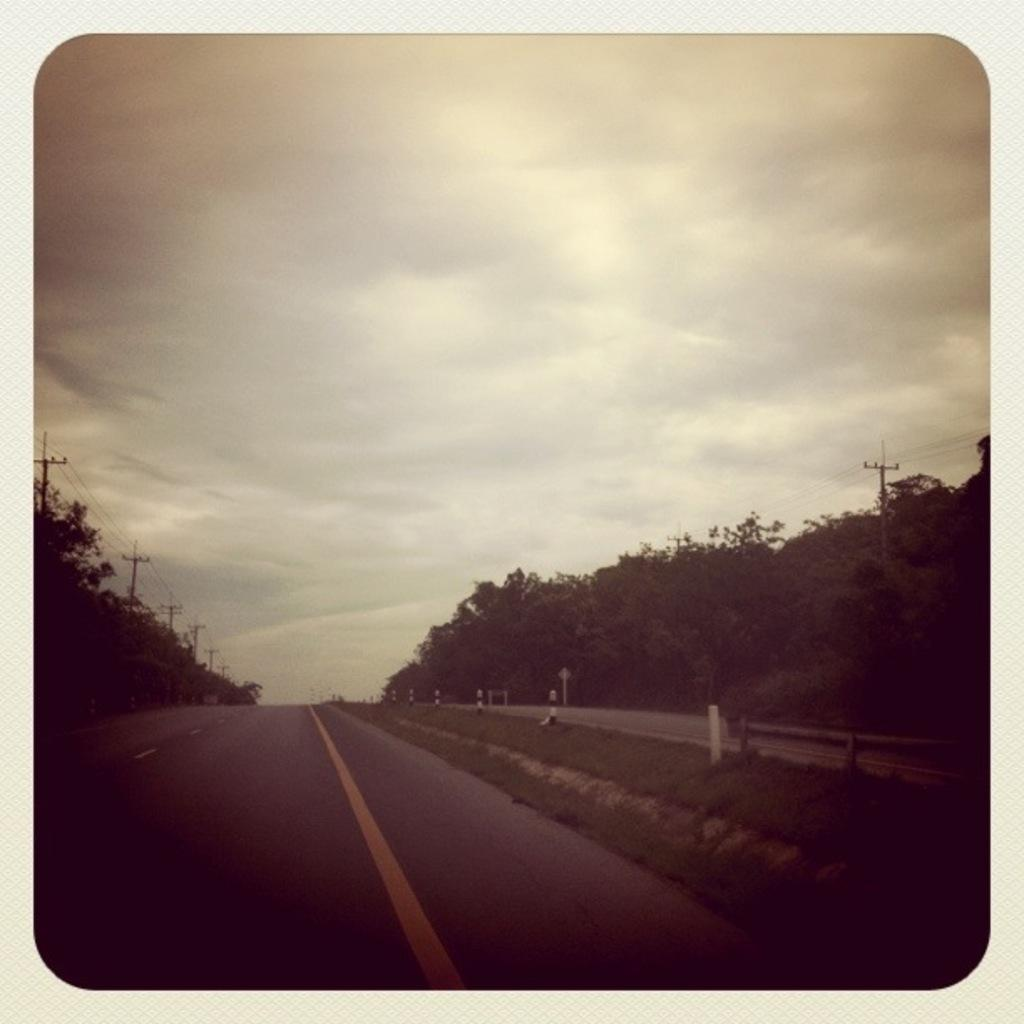What is the main feature of the image? There is a road in the image. What can be seen on either side of the road? There are trees on either side of the road. What is visible in the sky in the background of the image? There are clouds visible in the sky in the background of the image. How many toes can be seen on the trees in the image? Trees do not have toes, so none can be seen in the image. What level of respect is shown by the clouds in the image? Clouds do not exhibit respect, so this cannot be determined from the image. 